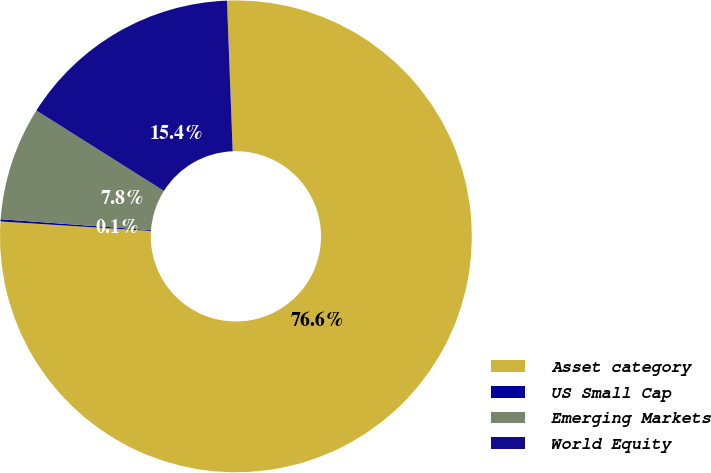<chart> <loc_0><loc_0><loc_500><loc_500><pie_chart><fcel>Asset category<fcel>US Small Cap<fcel>Emerging Markets<fcel>World Equity<nl><fcel>76.61%<fcel>0.15%<fcel>7.8%<fcel>15.44%<nl></chart> 